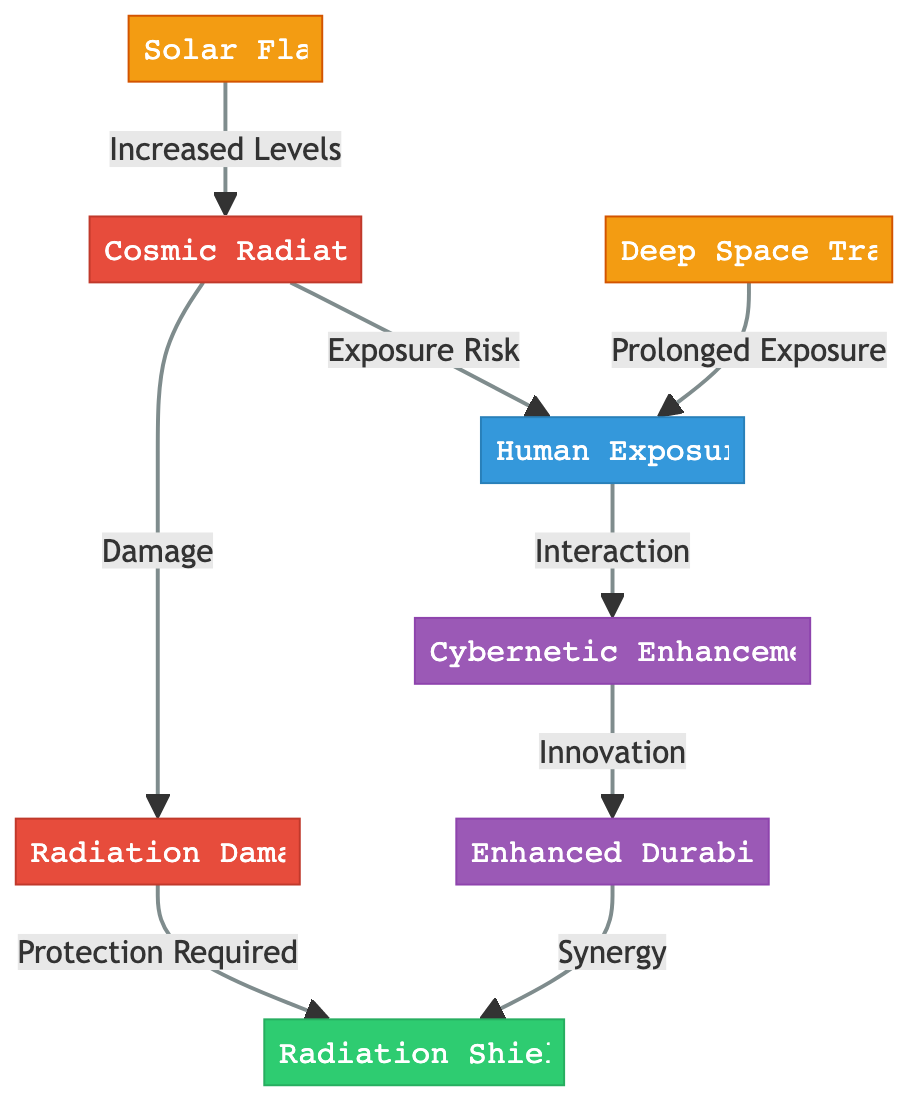What is the main source of radiation in this diagram? The diagram identifies "Cosmic Radiation" as the primary node representing the source of radiation. It is the first node in the flowchart and connects to other aspects related to human exposure and radiation damage.
Answer: Cosmic Radiation What is the relationship between "Human Exposure" and "Cybernetic Enhancements"? "Human Exposure" interacts with "Cybernetic Enhancements" as shown by the direct connection from node 2 to node 3, indicating that exposure affects the development or performance of enhancements.
Answer: Interaction How many nodes are related to "Radiation"? The diagram includes three nodes that relate to "Radiation": "Cosmic Radiation," "Radiation Damage," and "Radiation Shielding." Counting these gives a total of three related nodes.
Answer: 3 What does "Radiation Damage" require for protection? The connection from "Radiation Damage" to "Radiation Shielding" indicates that protection is required to mitigate the impact or consequences of the damage.
Answer: Protection Required What is the effect of "Deep Space Travel" on "Human Exposure"? "Deep Space Travel" has a direct connection to "Human Exposure," indicating that prolonged exposure results from traveling in deep space, suggesting an increased risk for humans.
Answer: Prolonged Exposure How do "Enhanced Durability" and "Radiation Shielding" relate? There is a direct connection labeled "Synergy" from "Enhanced Durability" back to "Radiation Shielding," indicating that enhancements can improve protective measures against radiation.
Answer: Synergy What increases the levels of "Cosmic Radiation"? The node labeled "Solar Flares" is shown to increase the levels of "Cosmic Radiation," demonstrating a direct impact from solar events to radiation exposure levels.
Answer: Increased Levels Which node indicates a risk factor associated with radiation? The "Human Exposure" node indicates that there is an exposure risk stemming from "Cosmic Radiation," making it a risk factor for the effects of radiation.
Answer: Exposure Risk Which node is designated for protection against radiation? The diagram specifies "Radiation Shielding" as the protective measure required to defend against radiation damage, thereby addressing safety concerns.
Answer: Radiation Shielding 